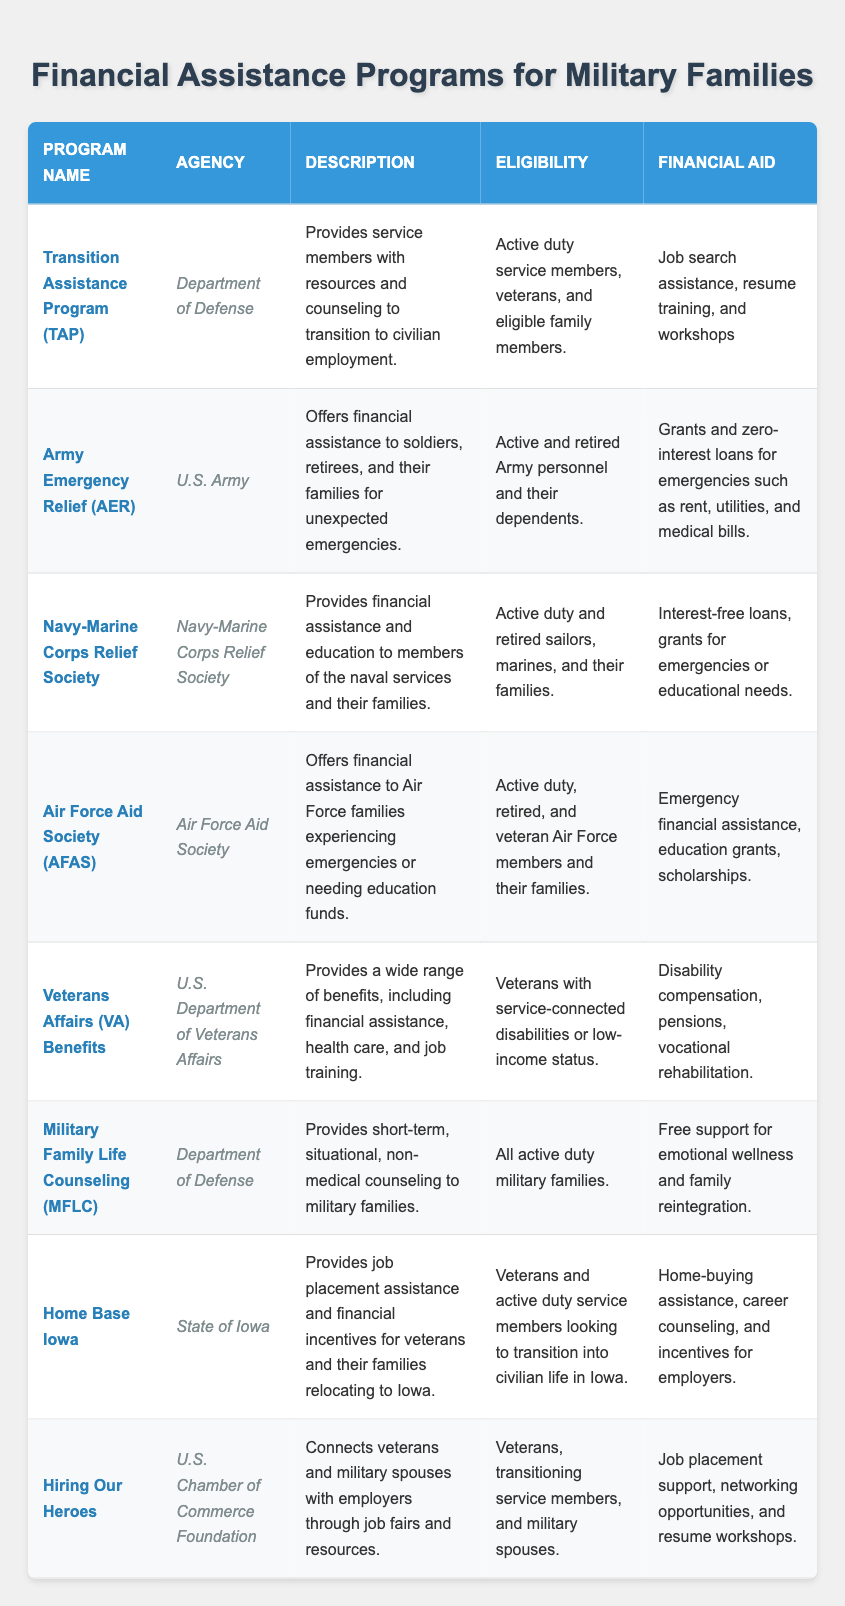What is the financial aid provided by the Transition Assistance Program (TAP)? The table states that the financial aid provided by TAP includes job search assistance, resume training, and workshops. Therefore, by looking at the respective row, we can directly find this information.
Answer: Job search assistance, resume training, and workshops Who is eligible for the Army Emergency Relief (AER) program? According to the information in the table, the AER program covers active and retired Army personnel and their dependents. This is explicitly mentioned in the eligibility column for AER.
Answer: Active and retired Army personnel and their dependents How many financial assistance programs offer grants? To find this, we need to review the financial aid descriptions of each program in the table. The programs that offer grants are Army Emergency Relief, Navy-Marine Corps Relief Society, Air Force Aid Society, Veterans Affairs Benefits, and Hiring Our Heroes. This gives us a total of 5 programs that provide grants.
Answer: 5 Is the Home Base Iowa program available for retired military personnel? The eligibility information for Home Base Iowa states that it is available for veterans and active duty service members. Since retired military personnel are not explicitly mentioned, we conclude that they do not qualify for Home Base Iowa.
Answer: No Which agency administers the Military Family Life Counseling (MFLC) program? From the table, the MFLC program is administered by the Department of Defense, which is found in the corresponding agency column for that program.
Answer: Department of Defense What financial aid does the Navy-Marine Corps Relief Society provide for educational needs? The financial aid provided by the Navy-Marine Corps Relief Society includes interest-free loans and grants for emergencies or educational needs. By examining the financial aid column of the respective row, we get this information.
Answer: Interest-free loans, grants for emergencies or educational needs Which program offers job placement support specifically for military spouses? The Hiring Our Heroes program explicitly mentions that it connects veterans and military spouses with employers through job fairs and resources. This detail is found under the description column.
Answer: Hiring Our Heroes How many programs provide emotional wellness support? Upon reviewing the table, only the Military Family Life Counseling (MFLC) program is dedicated to providing support for emotional wellness, specifically for military families. Therefore, there is 1 program that offers this type of support.
Answer: 1 